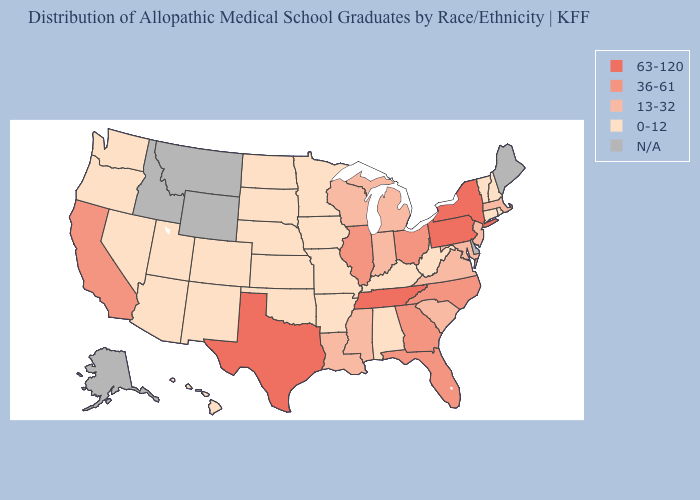What is the lowest value in states that border Missouri?
Quick response, please. 0-12. Among the states that border Oklahoma , which have the highest value?
Quick response, please. Texas. What is the value of North Dakota?
Give a very brief answer. 0-12. Name the states that have a value in the range 13-32?
Concise answer only. Indiana, Louisiana, Maryland, Massachusetts, Michigan, Mississippi, New Jersey, South Carolina, Virginia, Wisconsin. Name the states that have a value in the range 63-120?
Quick response, please. New York, Pennsylvania, Tennessee, Texas. Does Pennsylvania have the highest value in the USA?
Answer briefly. Yes. What is the lowest value in the USA?
Keep it brief. 0-12. Does Iowa have the lowest value in the USA?
Give a very brief answer. Yes. What is the value of Ohio?
Concise answer only. 36-61. What is the highest value in the West ?
Short answer required. 36-61. Does the map have missing data?
Concise answer only. Yes. Does the first symbol in the legend represent the smallest category?
Be succinct. No. Name the states that have a value in the range 0-12?
Write a very short answer. Alabama, Arizona, Arkansas, Colorado, Connecticut, Hawaii, Iowa, Kansas, Kentucky, Minnesota, Missouri, Nebraska, Nevada, New Hampshire, New Mexico, North Dakota, Oklahoma, Oregon, Rhode Island, South Dakota, Utah, Vermont, Washington, West Virginia. Which states have the highest value in the USA?
Write a very short answer. New York, Pennsylvania, Tennessee, Texas. 